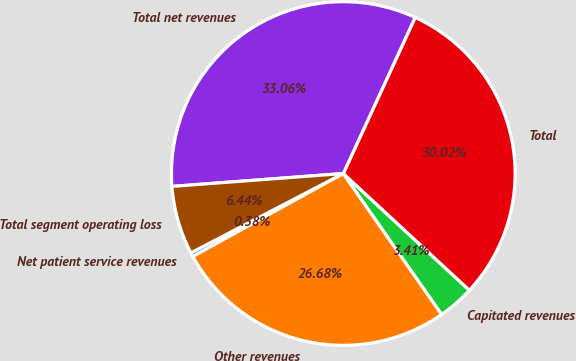Convert chart. <chart><loc_0><loc_0><loc_500><loc_500><pie_chart><fcel>Net patient service revenues<fcel>Other revenues<fcel>Capitated revenues<fcel>Total<fcel>Total net revenues<fcel>Total segment operating loss<nl><fcel>0.38%<fcel>26.68%<fcel>3.41%<fcel>30.02%<fcel>33.06%<fcel>6.44%<nl></chart> 